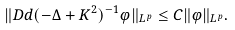<formula> <loc_0><loc_0><loc_500><loc_500>\| D d ( - \Delta + K ^ { 2 } ) ^ { - 1 } \varphi \| _ { L ^ { p } } \leq C \| \varphi \| _ { L ^ { p } } .</formula> 